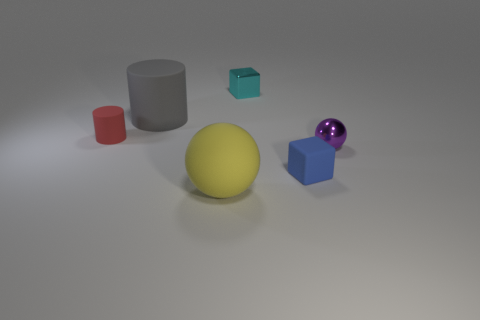What textures do the objects in the image have? The objects display a variety of textures. The yellow sphere and the gray cylinder have matte surfaces; the red cylinder has a slightly reflective surface. In contrast, the small metallic object and the purple sphere on the right exhibit highly reflective, glossy textures. 